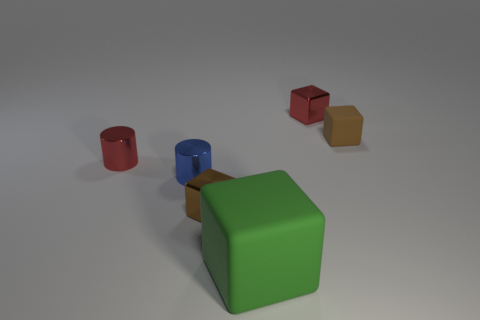Can you tell me about the colors of the objects in the image? Certainly! The image portrays a collection of colorful objects, including a green and a blue cube, a red cylinder, and a smaller red cube. The hues are quite vivid and create a nice contrast with the neutral background.  How could these objects be used to explain basic geometry to a child? These objects are perfect for a basic geometry lesson. Each one represents a fundamental shape: cubes and a cylinder. You can teach about edges, vertices, faces, and how to differentiate between 3D shapes based on these characteristics. Additionally, discussing the color of each shape can make the lesson more engaging for a child. 